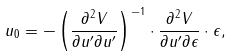<formula> <loc_0><loc_0><loc_500><loc_500>u _ { 0 } = - \left ( \frac { \partial ^ { 2 } V } { \partial u ^ { \prime } \partial u ^ { \prime } } \right ) ^ { - 1 } \cdot \frac { \partial ^ { 2 } V } { \partial u ^ { \prime } \partial \epsilon } \cdot \epsilon ,</formula> 